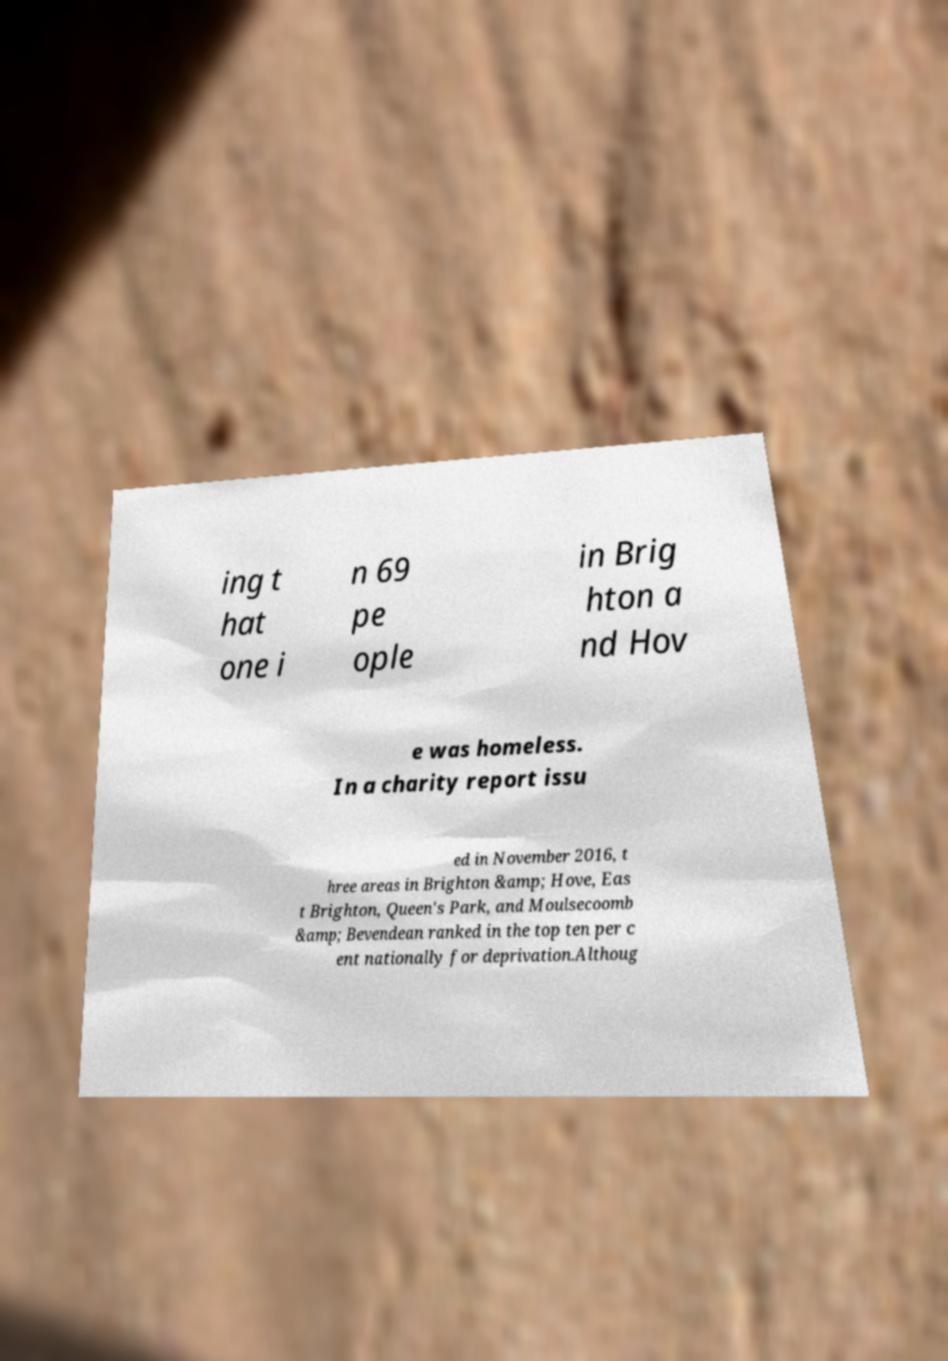Please read and relay the text visible in this image. What does it say? ing t hat one i n 69 pe ople in Brig hton a nd Hov e was homeless. In a charity report issu ed in November 2016, t hree areas in Brighton &amp; Hove, Eas t Brighton, Queen's Park, and Moulsecoomb &amp; Bevendean ranked in the top ten per c ent nationally for deprivation.Althoug 